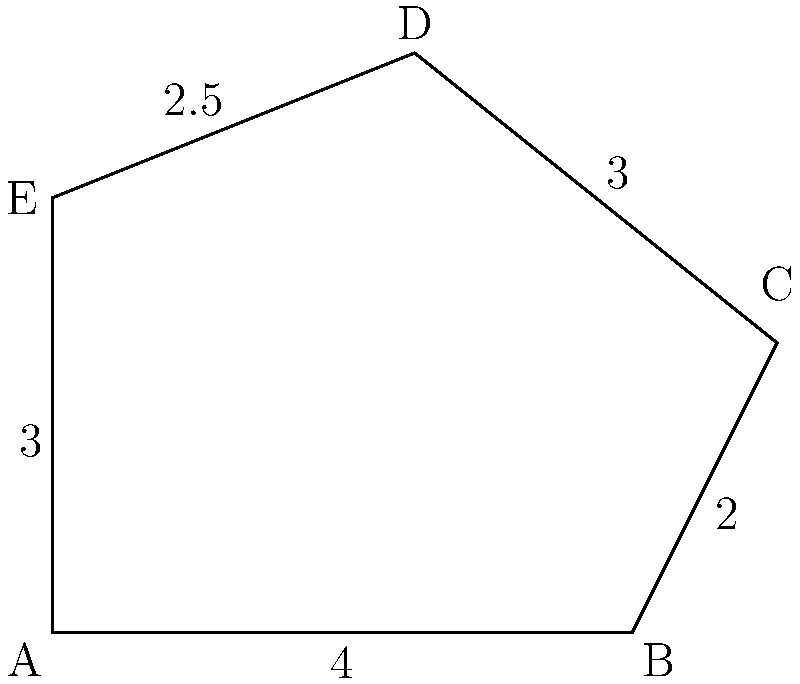In a dystopian world, a pentagonal fortress is designed to protect against societal collapse. The fortress's layout is shown in the diagram, with side lengths given in kilometers. If the perimeter of the fortress needs to be fortified with a special material that costs $250,000 per kilometer, what is the total cost of fortifying the entire perimeter? To solve this problem, we need to follow these steps:

1. Calculate the perimeter of the pentagonal fortress:
   - Sum up all side lengths: $4 + 2 + 3 + 2.5 + 3 = 14.5$ km

2. Calculate the cost of fortification:
   - Cost per kilometer: $250,000
   - Total length to fortify: 14.5 km
   - Total cost = $250,000 \times 14.5 = $3,625,000

Therefore, the total cost of fortifying the entire perimeter of the pentagonal fortress is $3,625,000.

This problem relates to the sociologist's interest in dystopian scenarios and societal vulnerabilities by presenting a practical challenge in protecting against societal collapse. It demonstrates how geometric principles can be applied to real-world situations in a post-apocalyptic context, highlighting the importance of resource management and strategic planning in times of crisis.
Answer: $3,625,000 